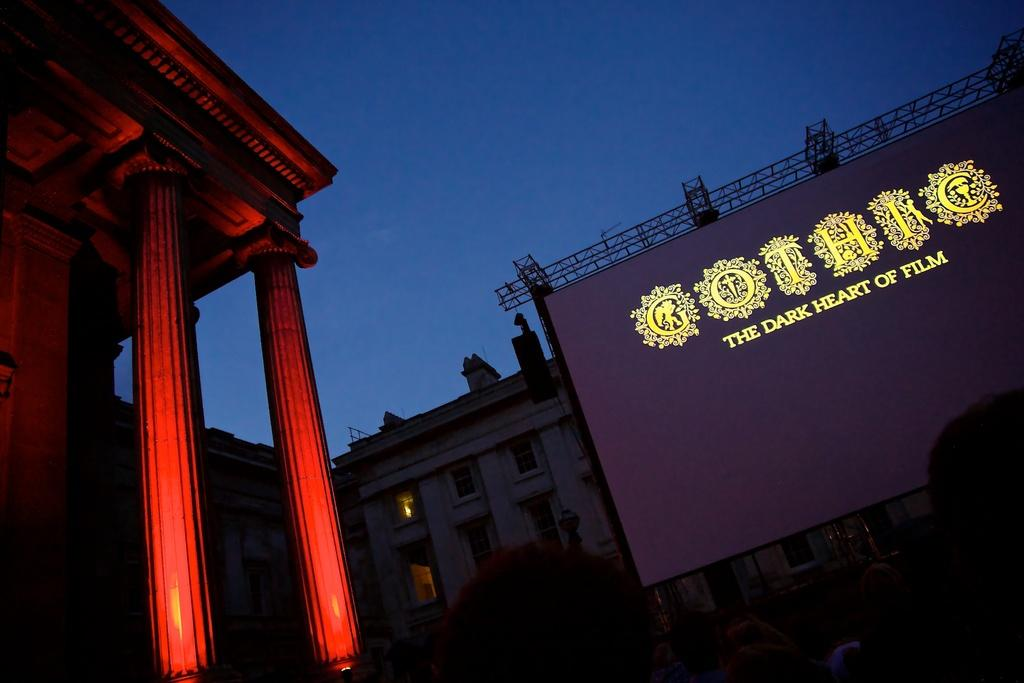What structure is located on the left side of the image? There is a building on the left side of the image. What can be seen on the right side of the image? There are persons and a screen on the right side of the image. What other structure is visible on the right side of the image? There is another building on the right side of the image. What is visible in the background of the image? The sky is visible in the background of the image. Can you tell me how many haircuts the grandfather received during his voyage in the image? There is no information about a grandfather or a voyage in the image, so it is not possible to answer that question. 